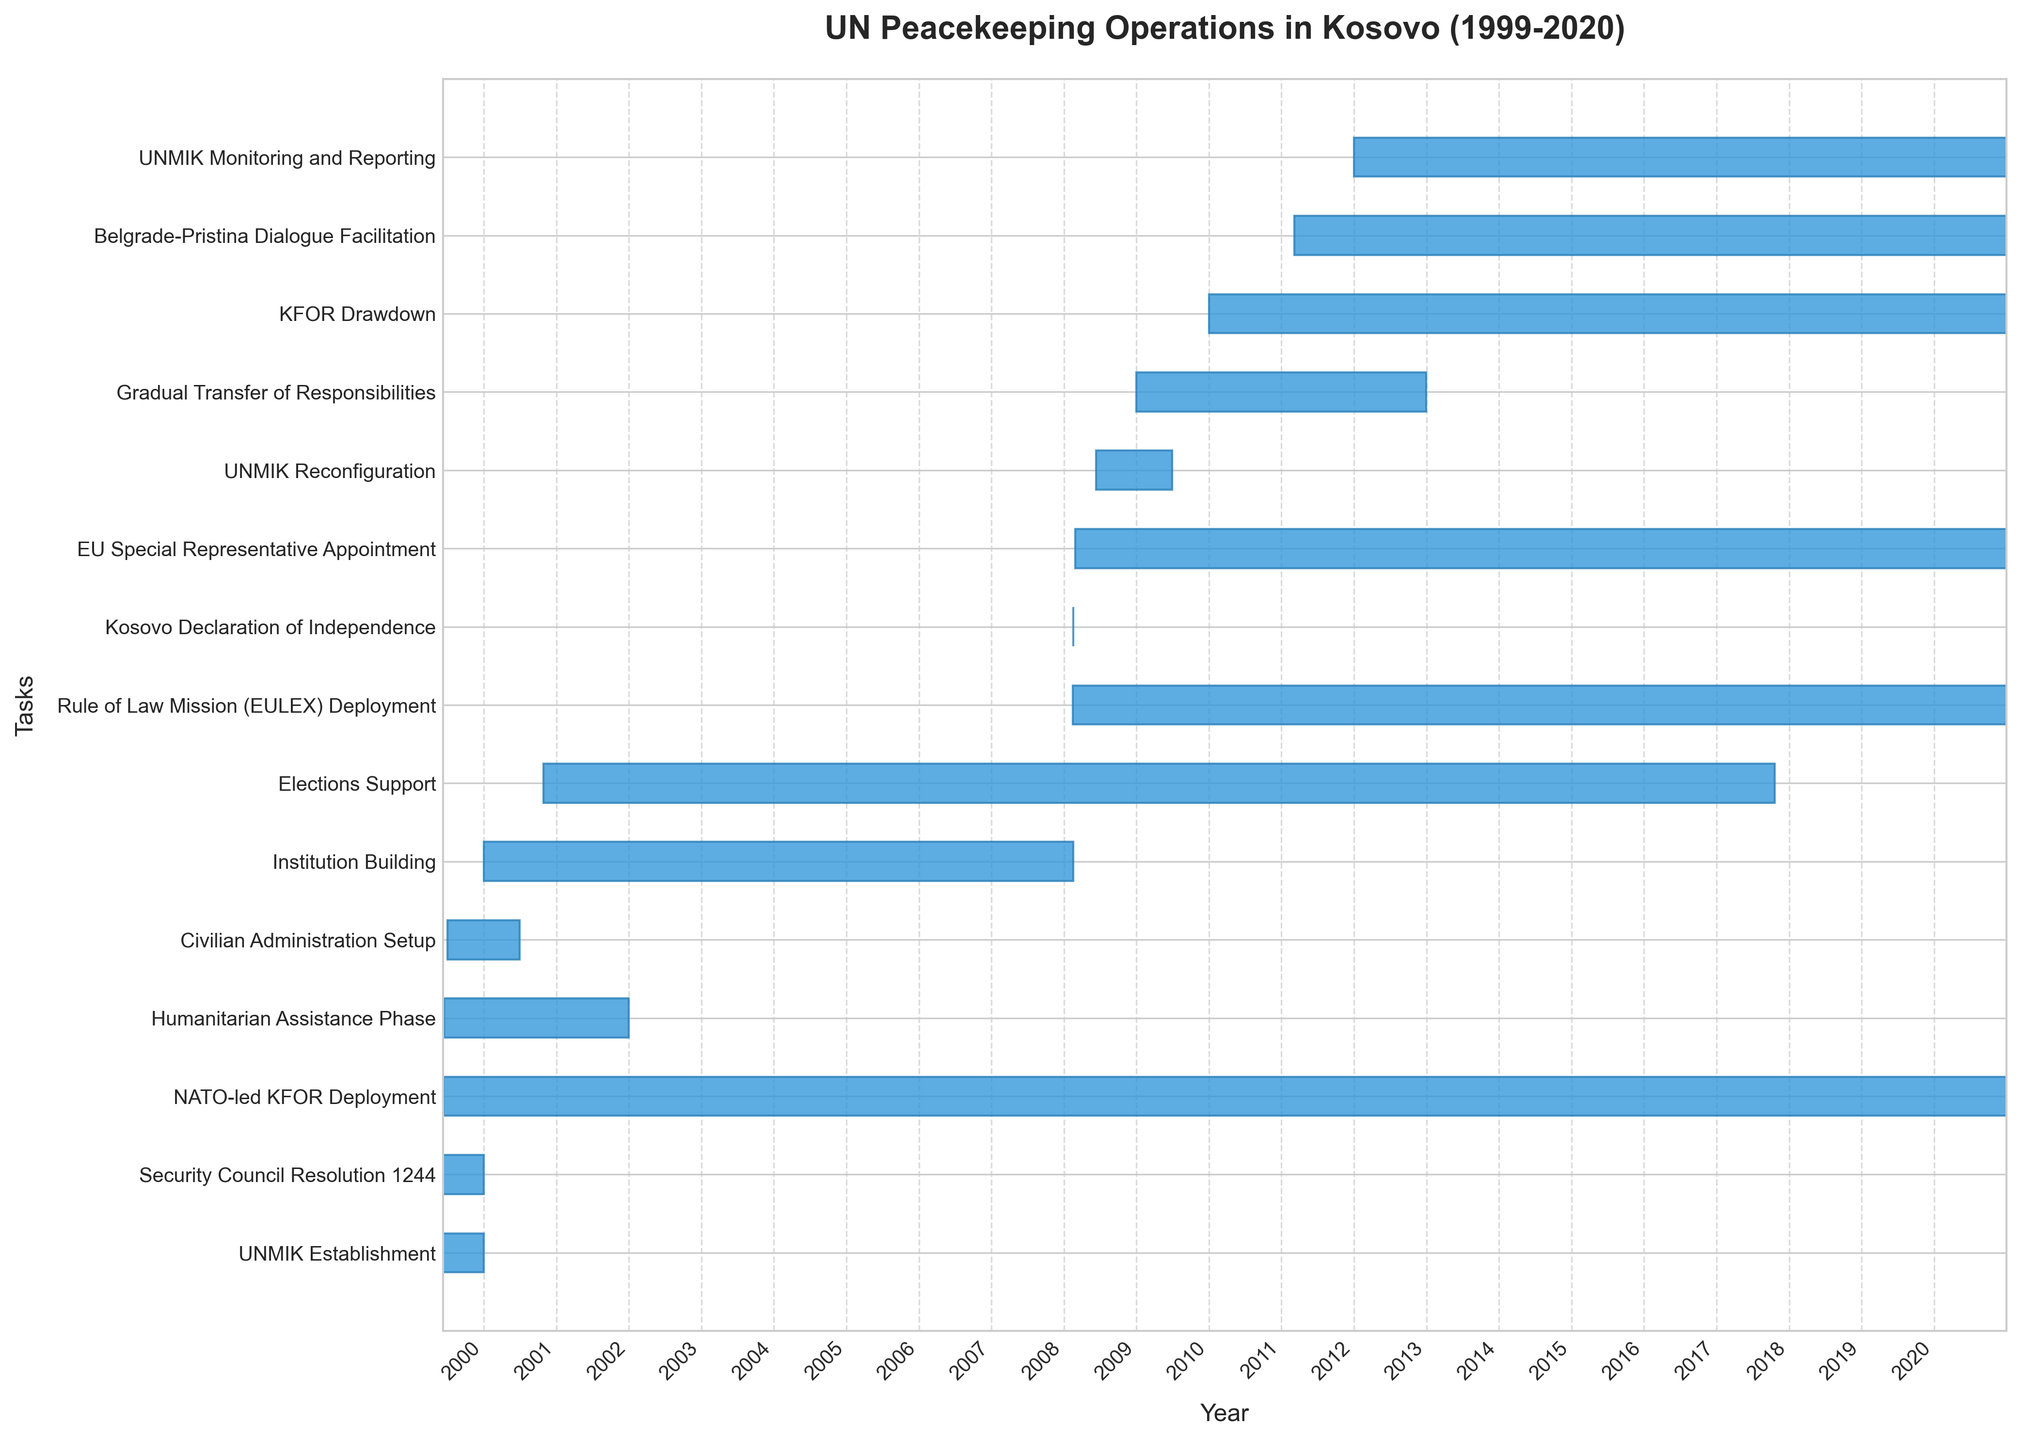Which task starts the latest according to the Gantt Chart? The latest starting task can be seen by looking at the rightmost position on the y-axis. "Belgrade-Pristina Dialogue Facilitation" starts in 2011.
Answer: Belgrade-Pristina Dialogue Facilitation What is the duration of the "Humanitarian Assistance Phase"? The duration of the "Humanitarian Assistance Phase" can be calculated by subtracting its start date (1999-06-15) from its end date (2001-12-31). This results in approximately 2 years and 6 months.
Answer: ~2 years, 6 months When did the "UNMIK Reconfiguration" task occur? By identifying its starting and ending points on the Gantt Chart, "UNMIK Reconfiguration" spans from mid-2008 to mid-2009.
Answer: Mid-2008 to mid-2009 How long did the "Institution Building" phase last? The "Institution Building" phase starts on 2000-01-01 and ends on 2008-02-17. Calculating the difference gives about 8 years and 1.5 months.
Answer: ~8 years, 1.5 months Which tasks were ongoing at the time of the "Kosovo Declaration of Independence" on 2008-02-17? Tasks ongoing during a specific date can be identified by checking which tasks' timelines intersect that date. "NATO-led KFOR Deployment," "Humanitarian Assistance Phase," "Institution Building," "Elections Support," and "Rule of Law Mission (EULEX) Deployment" were ongoing on 2008-02-17.
Answer: NATO-led KFOR Deployment, Humanitarian Assistance Phase, Institution Building, Elections Support, Rule of Law Mission (EULEX) Deployment How many years after the "Security Council Resolution 1244" establishment did the "KFOR Drawdown" start? "Security Council Resolution 1244" was established in mid-1999. "KFOR Drawdown" started in early 2010. The difference between 2010 and 1999 is approximately 11 years.
Answer: ~11 years What is the longest-running task in the chart? The longest-running task can be identified by looking for the bar that extends the furthest horizontally. "NATO-led KFOR Deployment" runs from 1999-06-12 to 2020-12-31, which is over 21 years.
Answer: NATO-led KFOR Deployment Which task has the shortest duration? The task with the shortest duration can be identified by finding the smallest horizontal bar. "Kosovo Declaration of Independence" lasts only one day, 2008-02-17.
Answer: Kosovo Declaration of Independence 